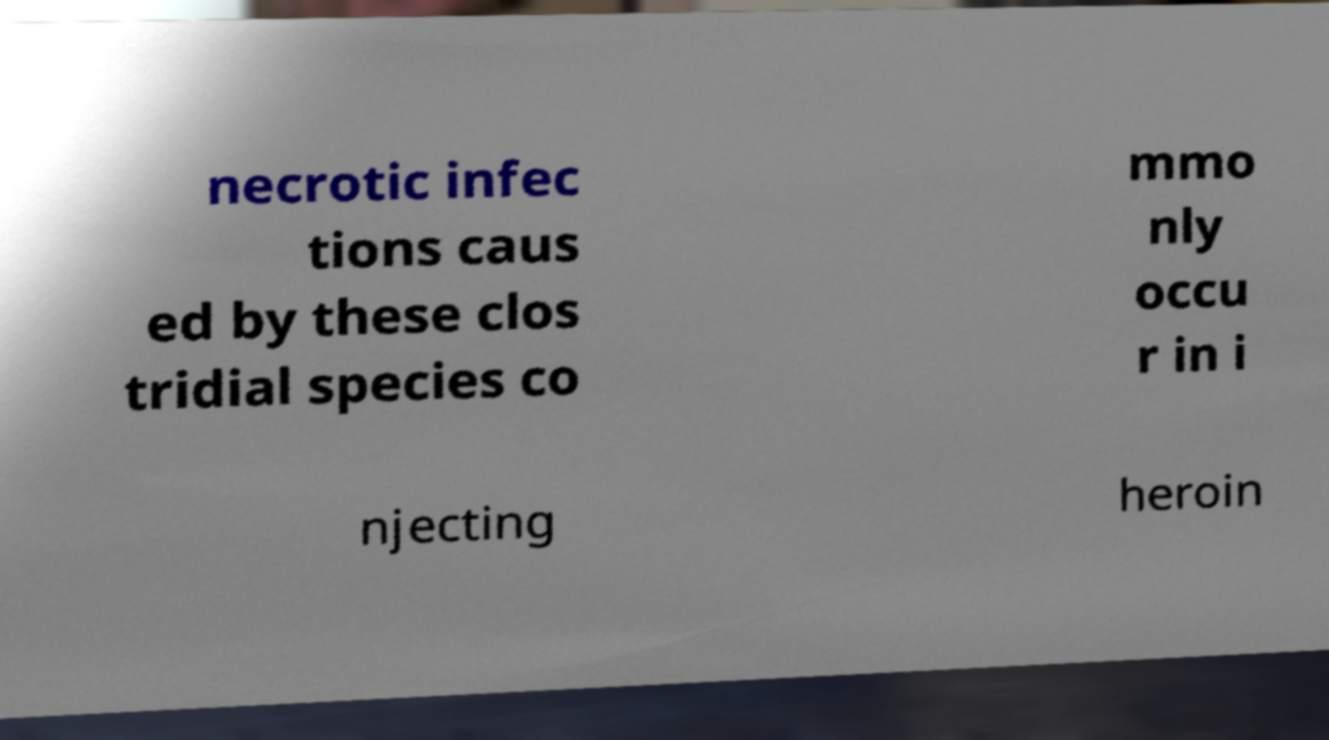Please read and relay the text visible in this image. What does it say? necrotic infec tions caus ed by these clos tridial species co mmo nly occu r in i njecting heroin 